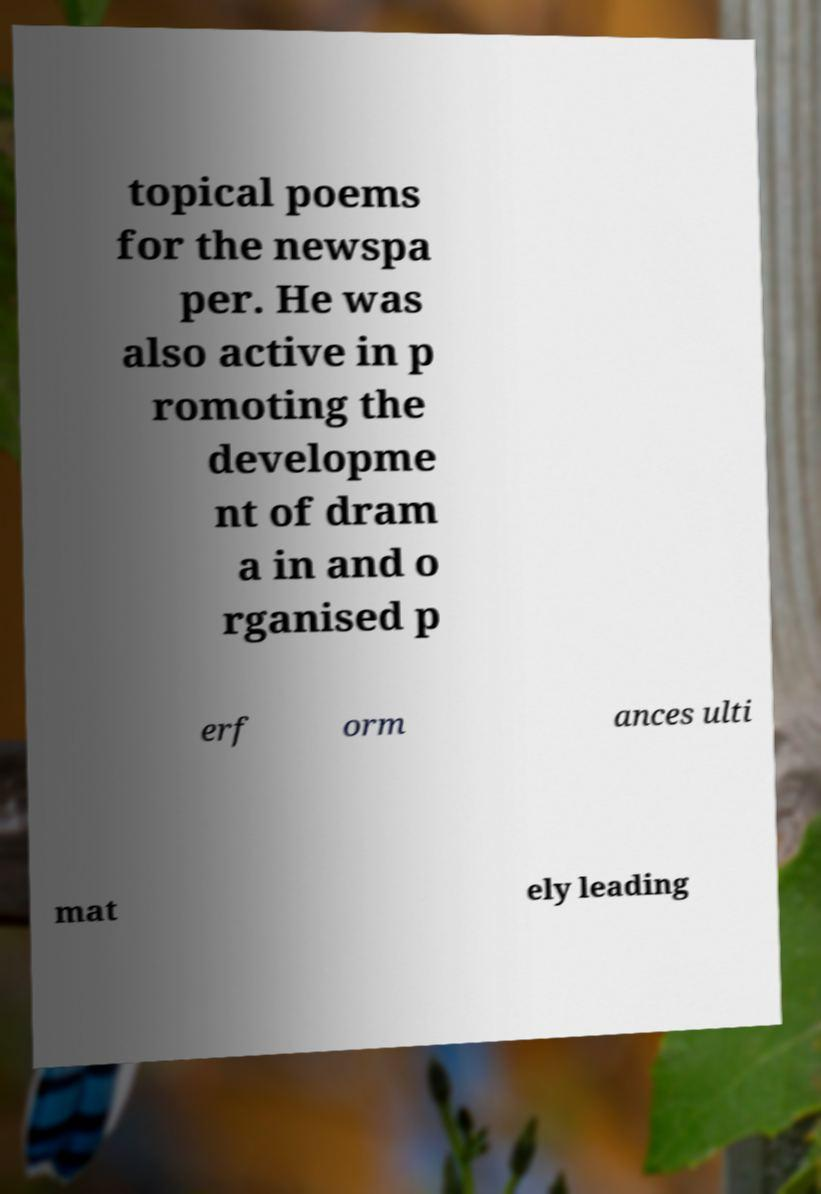Can you accurately transcribe the text from the provided image for me? topical poems for the newspa per. He was also active in p romoting the developme nt of dram a in and o rganised p erf orm ances ulti mat ely leading 